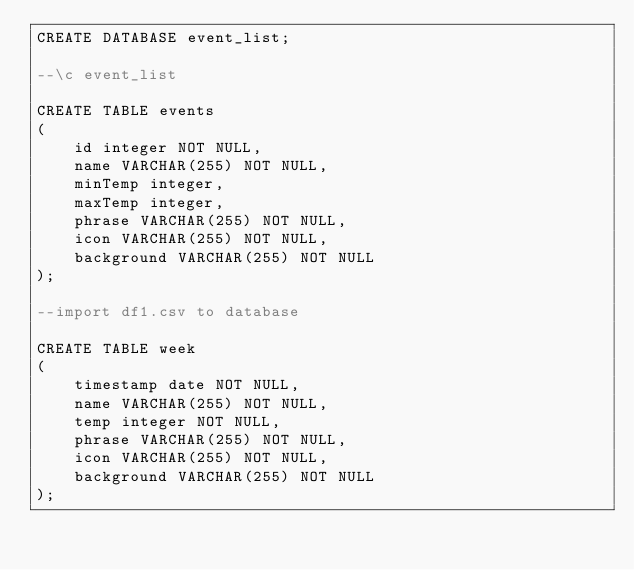<code> <loc_0><loc_0><loc_500><loc_500><_SQL_>CREATE DATABASE event_list;

--\c event_list

CREATE TABLE events
(
    id integer NOT NULL,
    name VARCHAR(255) NOT NULL,
    minTemp integer,
    maxTemp integer,
    phrase VARCHAR(255) NOT NULL,
    icon VARCHAR(255) NOT NULL,
    background VARCHAR(255) NOT NULL
);

--import df1.csv to database

CREATE TABLE week
(
    timestamp date NOT NULL,
    name VARCHAR(255) NOT NULL,
    temp integer NOT NULL,
    phrase VARCHAR(255) NOT NULL,
    icon VARCHAR(255) NOT NULL,
    background VARCHAR(255) NOT NULL
);</code> 